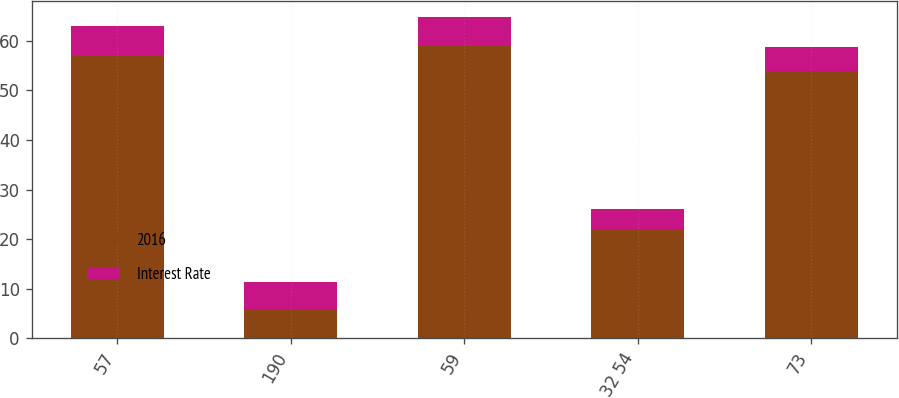<chart> <loc_0><loc_0><loc_500><loc_500><stacked_bar_chart><ecel><fcel>57<fcel>190<fcel>59<fcel>32 54<fcel>73<nl><fcel>2016<fcel>57<fcel>6<fcel>59<fcel>22<fcel>54<nl><fcel>Interest Rate<fcel>6<fcel>5.38<fcel>5.88<fcel>4.12<fcel>4.75<nl></chart> 